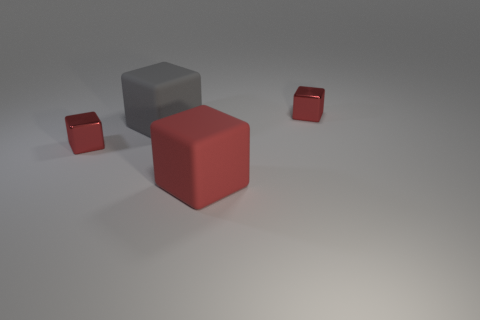Is there anything about the image that suggests it might have been created with a computer program? Yes, the perfection in the shapes of the cubes, the uniformity of the colors, and the clean, unadorned background are indicative that this is likely a computer-generated rendering. Additionally, the exact shadows and subtle light gradients are telltale signs of digital creation. 